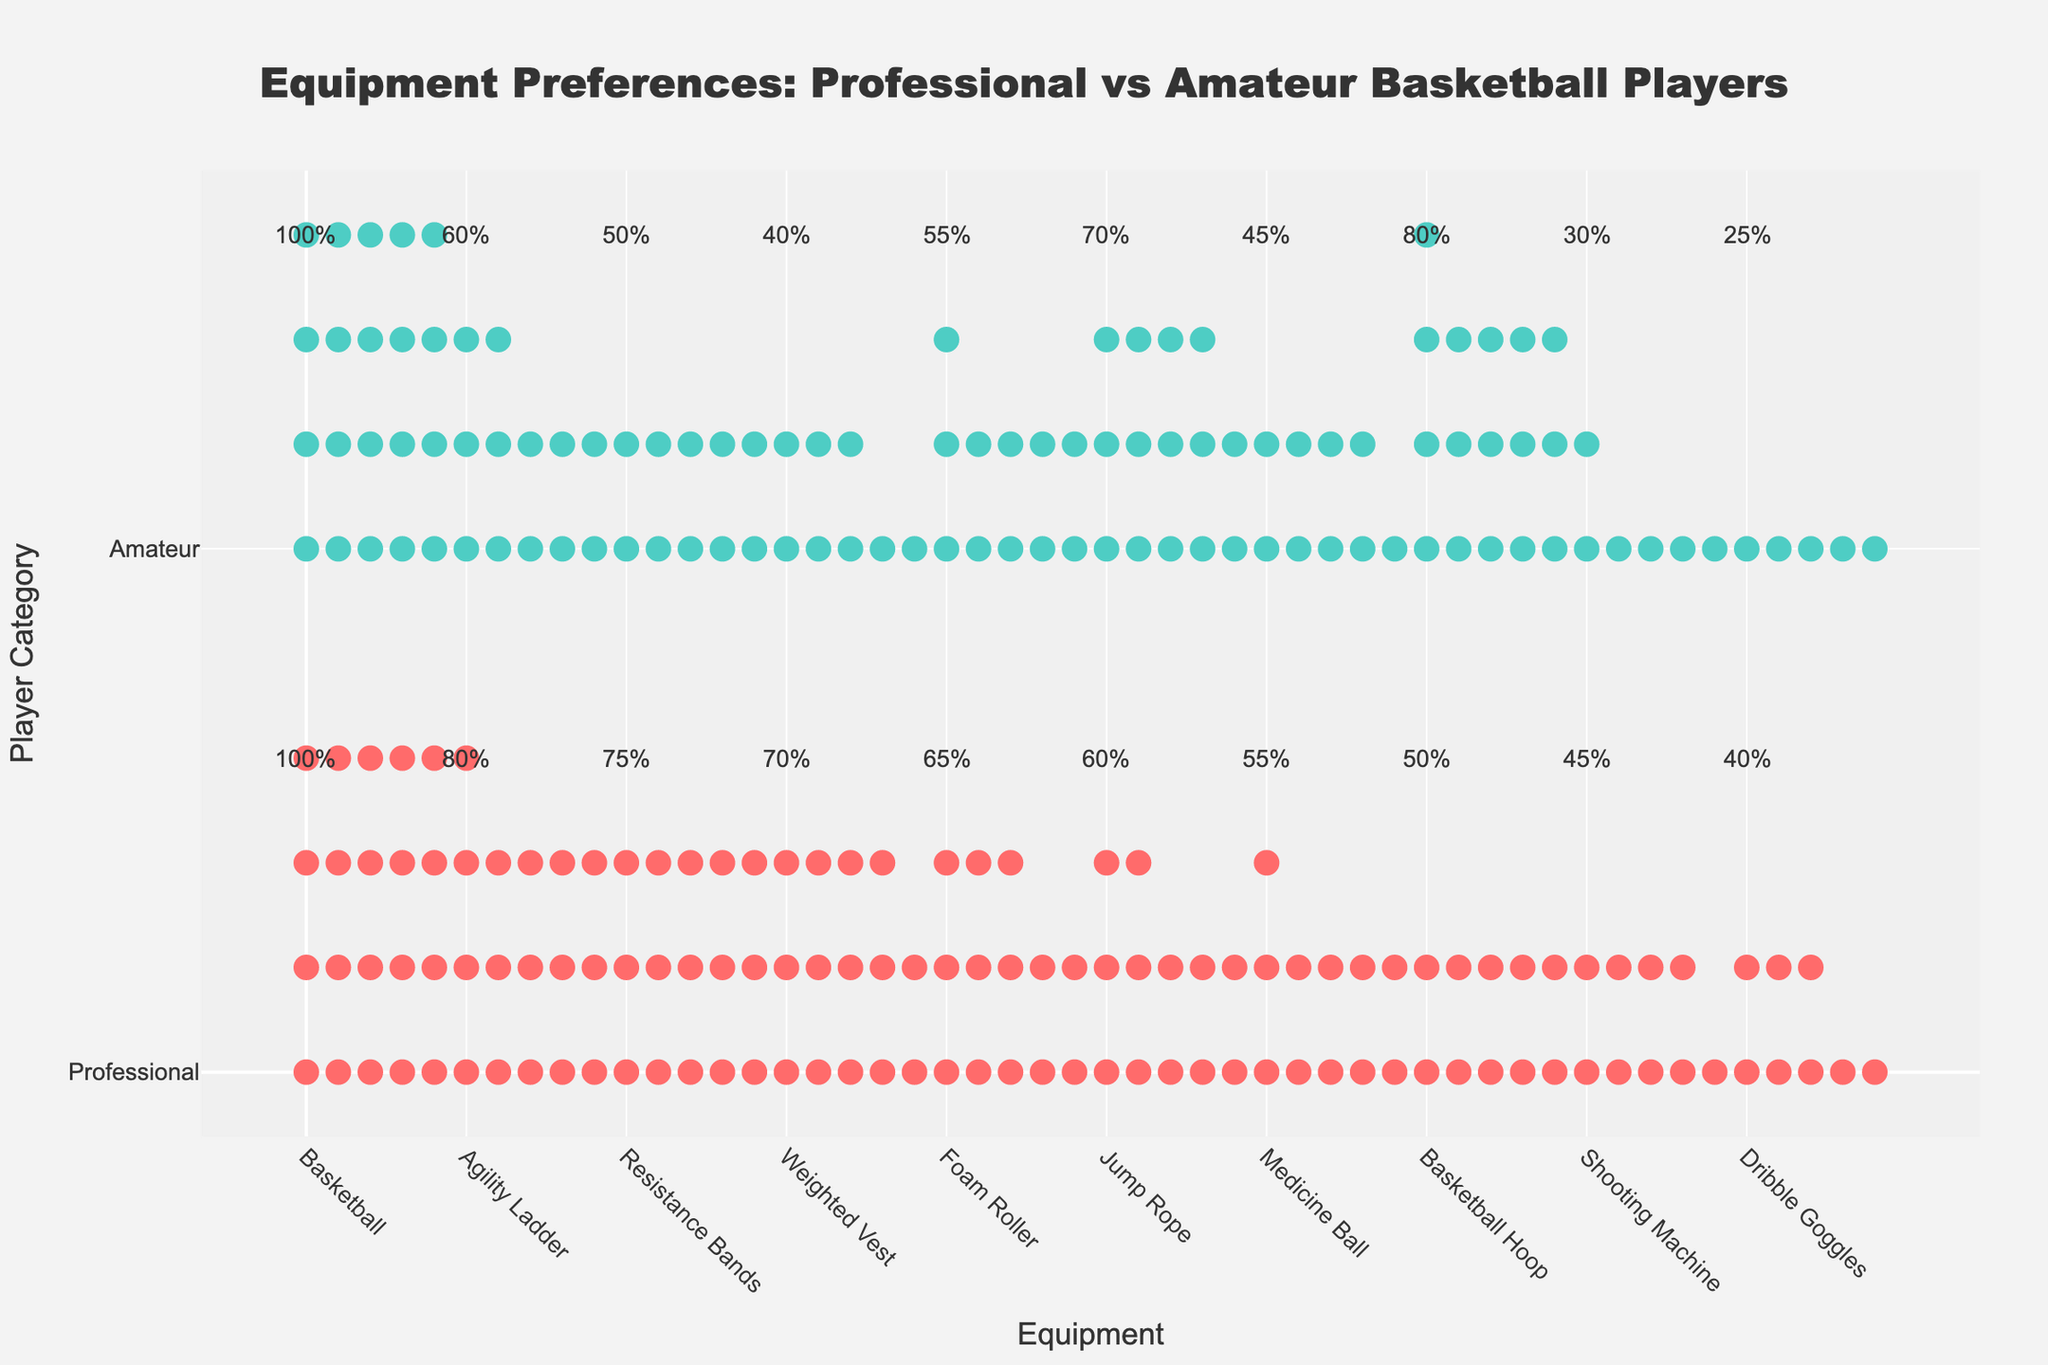what is the most preferred equipment among professional basketball players? By looking at the height of the markers in the 'Professional' category, the one with the highest markers represents the basketball, indicating it is most preferred.
Answer: Basketball Which equipment shows a clear preference difference between professional and amateur players? Observing the markers, the 'Basketball Hoop' has a visible preference difference with professionals at 50% and amateurs at 80%.
Answer: Basketball Hoop How do the preferences for agility ladders differ between professional and amateur players? The 'Agility Ladder' is used by 80% of professionals and 60% of amateurs, showing a 20% difference in preference.
Answer: 20% Are resistance bands more favored by professionals or amateurs, and by how much? Professionals prefer 'Resistance Bands' at 75%, whereas amateurs prefer at 50%. The difference is 25%.
Answer: Professionals, 25% What equipment is equally preferred by both professional and amateur players? 'Basketball' is preferred by 100% for both professional and amateur players as indicated by 20 markers each in both categories.
Answer: Basketball Which player category prefers jump ropes more, and what is the percentage difference? Amateurs prefer 'Jump Rope' at 70%, while professionals prefer it at 60%, showing a 10% higher preference among amateurs.
Answer: Amateurs, 10% Rank the top three preferred equipment by amateur players. By reviewing the height of markers for amateurs, the top three are 'Basketball' (100%), 'Basketball Hoop' (80%), and 'Jump Rope' (70%).
Answer: Basketball, Basketball Hoop, Jump Rope What is the total preference percentage for 'Weighted Vest' by both categories combined? Adding both professional and amateur preferences for 'Weighted Vest,' we get 70% + 40% = 110%.
Answer: 110% Which equipment is the least preferred by professional players, and how many prefer it? The 'Dribble Goggles' are least preferred by professionals at 40%, as indicated by the lowest number of markers.
Answer: Dribble Goggles, 40% How many pieces of equipment have a higher preference percentage among professionals compared to amateurs? Counting the categories with more markers for professionals, we have 'Agility Ladder,' 'Resistance Bands,' 'Weighted Vest,' 'Foam Roller,' 'Medicine Ball,' and 'Shooting Machine,' totaling 6.
Answer: 6 